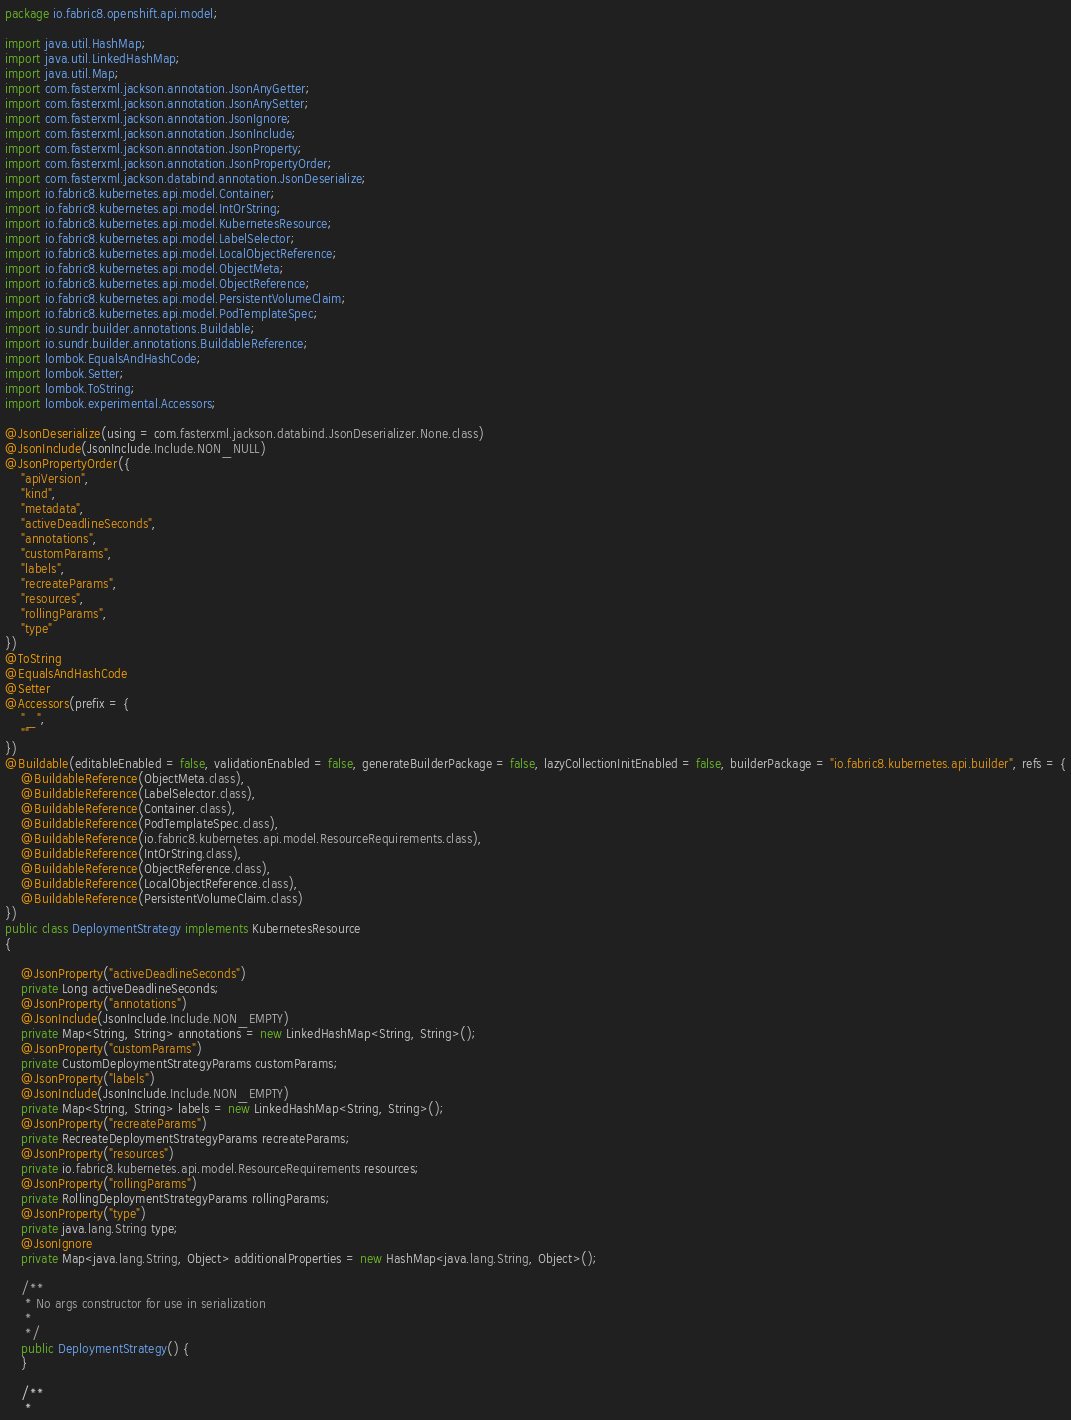Convert code to text. <code><loc_0><loc_0><loc_500><loc_500><_Java_>
package io.fabric8.openshift.api.model;

import java.util.HashMap;
import java.util.LinkedHashMap;
import java.util.Map;
import com.fasterxml.jackson.annotation.JsonAnyGetter;
import com.fasterxml.jackson.annotation.JsonAnySetter;
import com.fasterxml.jackson.annotation.JsonIgnore;
import com.fasterxml.jackson.annotation.JsonInclude;
import com.fasterxml.jackson.annotation.JsonProperty;
import com.fasterxml.jackson.annotation.JsonPropertyOrder;
import com.fasterxml.jackson.databind.annotation.JsonDeserialize;
import io.fabric8.kubernetes.api.model.Container;
import io.fabric8.kubernetes.api.model.IntOrString;
import io.fabric8.kubernetes.api.model.KubernetesResource;
import io.fabric8.kubernetes.api.model.LabelSelector;
import io.fabric8.kubernetes.api.model.LocalObjectReference;
import io.fabric8.kubernetes.api.model.ObjectMeta;
import io.fabric8.kubernetes.api.model.ObjectReference;
import io.fabric8.kubernetes.api.model.PersistentVolumeClaim;
import io.fabric8.kubernetes.api.model.PodTemplateSpec;
import io.sundr.builder.annotations.Buildable;
import io.sundr.builder.annotations.BuildableReference;
import lombok.EqualsAndHashCode;
import lombok.Setter;
import lombok.ToString;
import lombok.experimental.Accessors;

@JsonDeserialize(using = com.fasterxml.jackson.databind.JsonDeserializer.None.class)
@JsonInclude(JsonInclude.Include.NON_NULL)
@JsonPropertyOrder({
    "apiVersion",
    "kind",
    "metadata",
    "activeDeadlineSeconds",
    "annotations",
    "customParams",
    "labels",
    "recreateParams",
    "resources",
    "rollingParams",
    "type"
})
@ToString
@EqualsAndHashCode
@Setter
@Accessors(prefix = {
    "_",
    ""
})
@Buildable(editableEnabled = false, validationEnabled = false, generateBuilderPackage = false, lazyCollectionInitEnabled = false, builderPackage = "io.fabric8.kubernetes.api.builder", refs = {
    @BuildableReference(ObjectMeta.class),
    @BuildableReference(LabelSelector.class),
    @BuildableReference(Container.class),
    @BuildableReference(PodTemplateSpec.class),
    @BuildableReference(io.fabric8.kubernetes.api.model.ResourceRequirements.class),
    @BuildableReference(IntOrString.class),
    @BuildableReference(ObjectReference.class),
    @BuildableReference(LocalObjectReference.class),
    @BuildableReference(PersistentVolumeClaim.class)
})
public class DeploymentStrategy implements KubernetesResource
{

    @JsonProperty("activeDeadlineSeconds")
    private Long activeDeadlineSeconds;
    @JsonProperty("annotations")
    @JsonInclude(JsonInclude.Include.NON_EMPTY)
    private Map<String, String> annotations = new LinkedHashMap<String, String>();
    @JsonProperty("customParams")
    private CustomDeploymentStrategyParams customParams;
    @JsonProperty("labels")
    @JsonInclude(JsonInclude.Include.NON_EMPTY)
    private Map<String, String> labels = new LinkedHashMap<String, String>();
    @JsonProperty("recreateParams")
    private RecreateDeploymentStrategyParams recreateParams;
    @JsonProperty("resources")
    private io.fabric8.kubernetes.api.model.ResourceRequirements resources;
    @JsonProperty("rollingParams")
    private RollingDeploymentStrategyParams rollingParams;
    @JsonProperty("type")
    private java.lang.String type;
    @JsonIgnore
    private Map<java.lang.String, Object> additionalProperties = new HashMap<java.lang.String, Object>();

    /**
     * No args constructor for use in serialization
     * 
     */
    public DeploymentStrategy() {
    }

    /**
     * </code> 